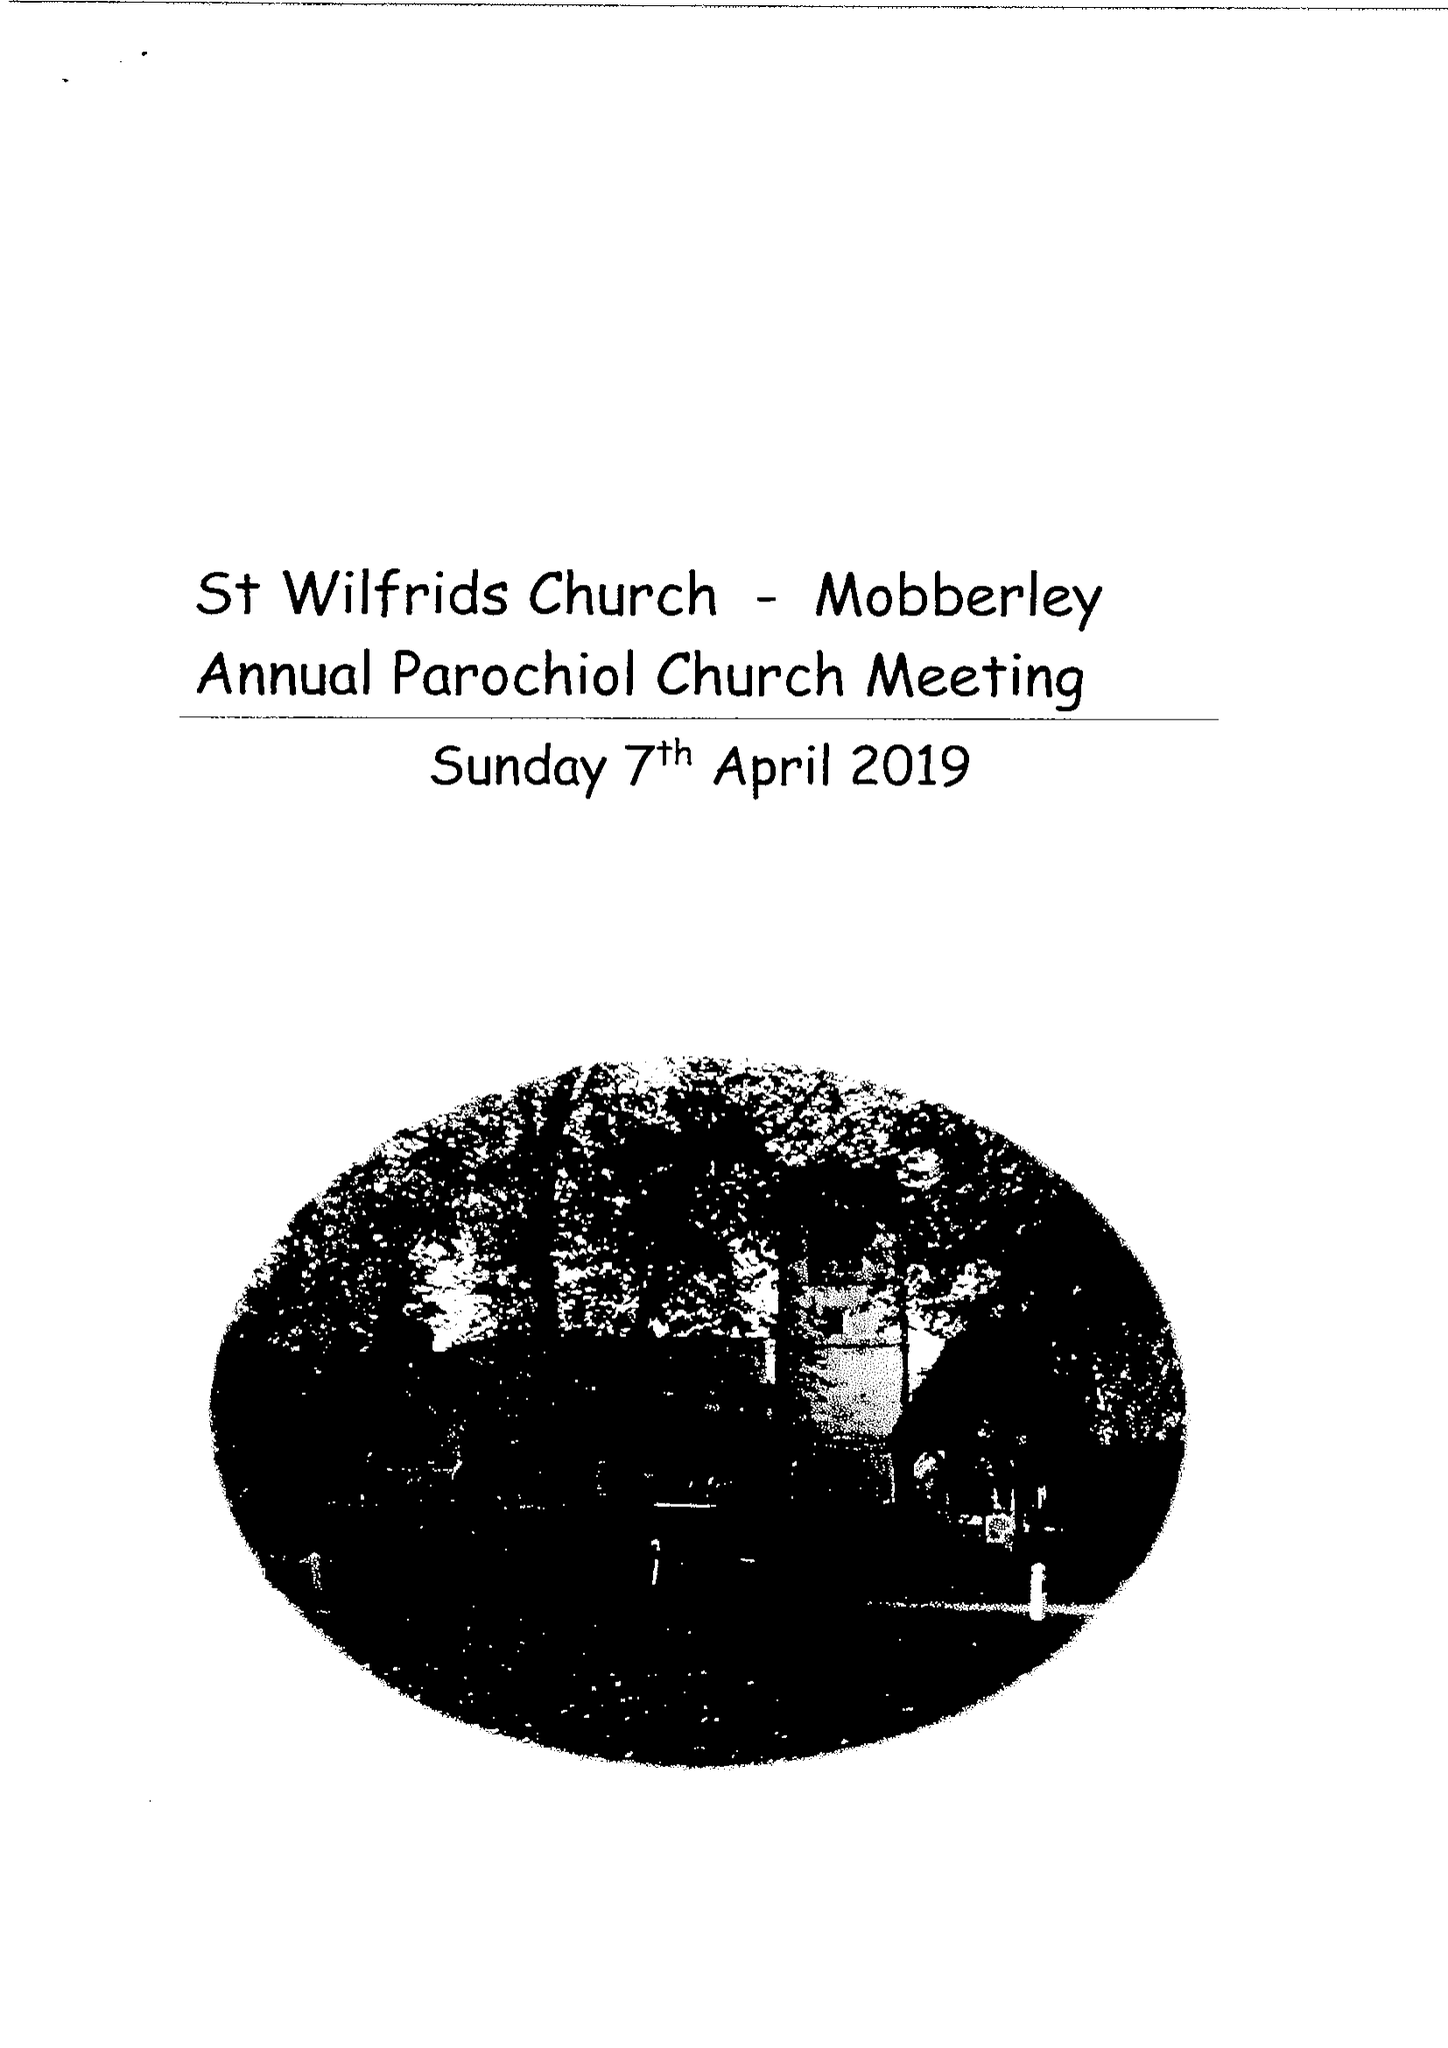What is the value for the address__postcode?
Answer the question using a single word or phrase. WA16 7RS 